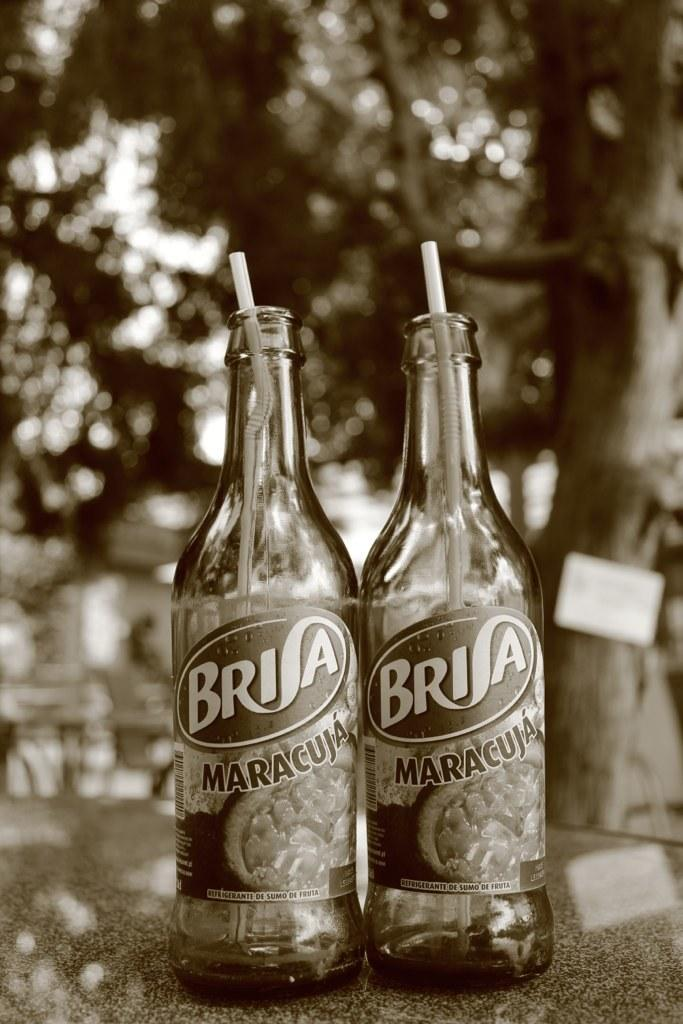<image>
Relay a brief, clear account of the picture shown. Two bottles of Brisa with straws in them outdoors by a tree. 